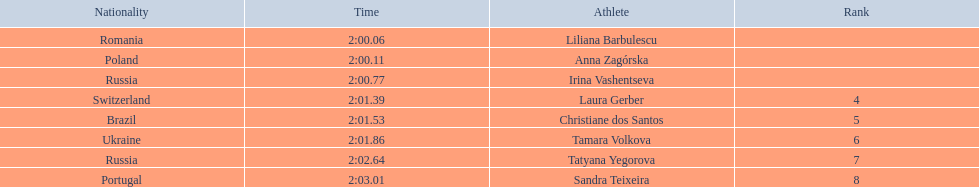Who were all of the athletes? Liliana Barbulescu, Anna Zagórska, Irina Vashentseva, Laura Gerber, Christiane dos Santos, Tamara Volkova, Tatyana Yegorova, Sandra Teixeira. What were their finishing times? 2:00.06, 2:00.11, 2:00.77, 2:01.39, 2:01.53, 2:01.86, 2:02.64, 2:03.01. Which athlete finished earliest? Liliana Barbulescu. 